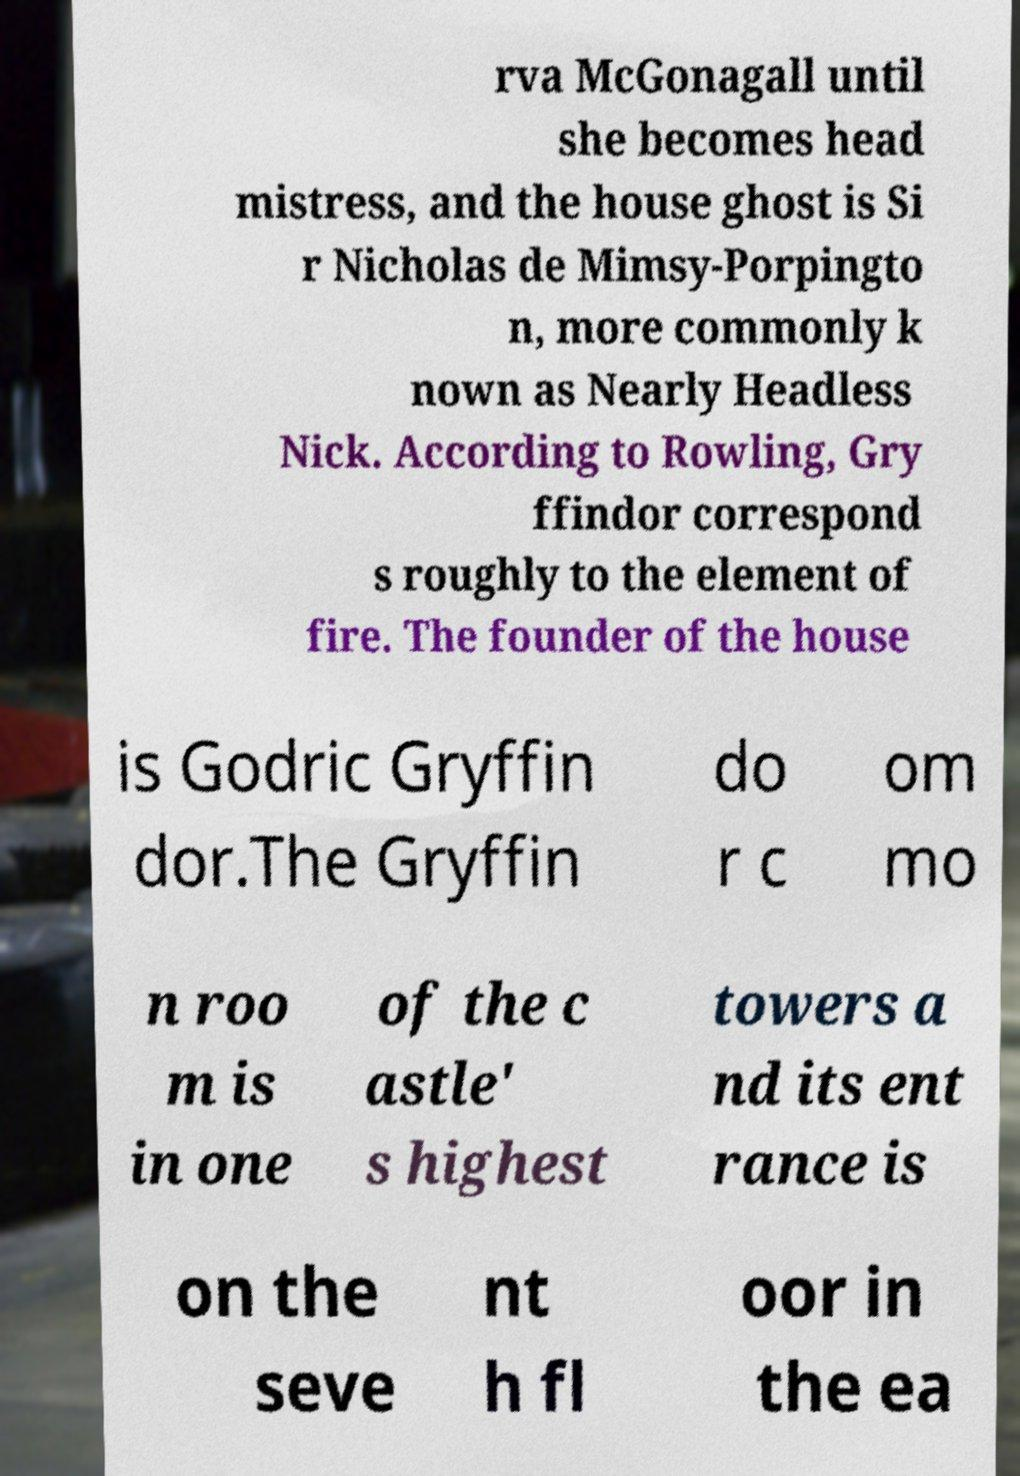Can you read and provide the text displayed in the image?This photo seems to have some interesting text. Can you extract and type it out for me? rva McGonagall until she becomes head mistress, and the house ghost is Si r Nicholas de Mimsy-Porpingto n, more commonly k nown as Nearly Headless Nick. According to Rowling, Gry ffindor correspond s roughly to the element of fire. The founder of the house is Godric Gryffin dor.The Gryffin do r c om mo n roo m is in one of the c astle' s highest towers a nd its ent rance is on the seve nt h fl oor in the ea 